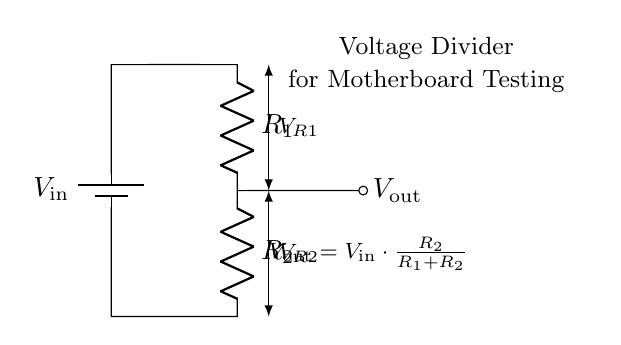What are the two resistors in this circuit? The circuit diagram shows two resistors labeled as R1 and R2. They are in series and part of the voltage divider configuration.
Answer: R1, R2 What is the formula for Vout in this circuit? The voltage output (Vout) is given by the formula: Vout = Vin * (R2 / (R1 + R2)), indicating how the input voltage is divided across the resistors.
Answer: Vout = Vin * (R2 / (R1 + R2)) What is the role of the battery in this circuit? The battery, labeled Vin, provides the input voltage for the circuit, which is essential for the operation of the voltage divider.
Answer: Input voltage What does Vout represent in this voltage divider? Vout represents the voltage drop across R2 and is the output voltage derived from the input voltage and the resistor values in the voltage divider.
Answer: Output voltage If R1 is twice the value of R2, what can be inferred about Vout? If R1 is twice R2, then according to the voltage divider formula, Vout will be one-third of Vin, meaning the output voltage will be lower since R1 has a greater influence on the division.
Answer: One-third of Vin How are the resistors connected in this circuit? The resistors R1 and R2 are connected in series, which means that the total voltage is split between them.
Answer: In series 